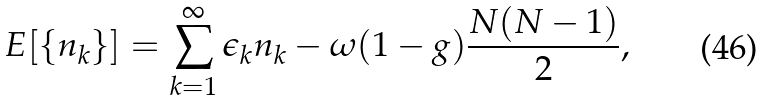<formula> <loc_0><loc_0><loc_500><loc_500>E [ \{ n _ { k } \} ] = \sum _ { k = 1 } ^ { \infty } \epsilon _ { k } n _ { k } - \omega ( 1 - g ) \frac { N ( N - 1 ) } { 2 } ,</formula> 